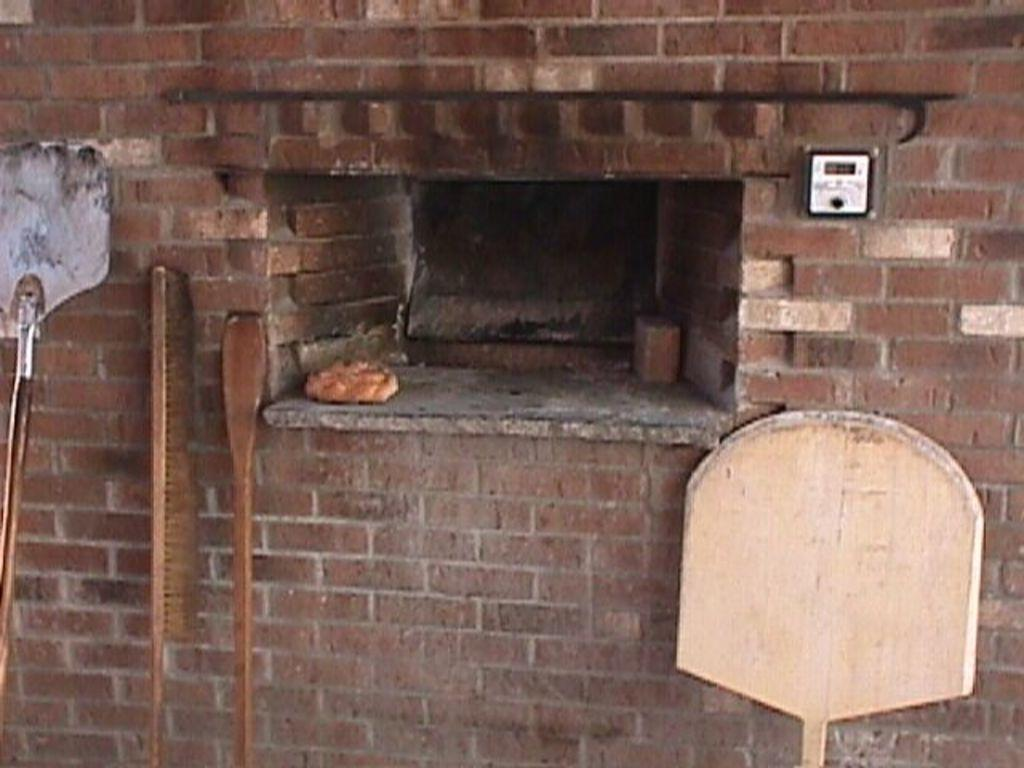What objects can be seen in the image? There are sticks in the image. Can you describe the background of the image? There is a meter placed on the wall in the background of the image. What type of boot is hanging from the rail in the image? There is no boot or rail present in the image; it only features sticks and a meter on the wall. 